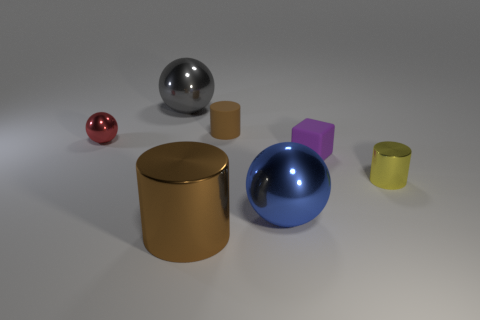Do the big brown shiny object and the yellow thing have the same shape?
Offer a very short reply. Yes. What is the color of the small rubber block?
Provide a succinct answer. Purple. What number of other objects are there of the same material as the yellow cylinder?
Keep it short and to the point. 4. What number of red objects are blocks or big spheres?
Your response must be concise. 0. Does the purple rubber thing in front of the tiny brown object have the same shape as the metal object to the right of the purple block?
Provide a short and direct response. No. There is a small metal ball; is its color the same as the metallic object behind the small brown matte cylinder?
Ensure brevity in your answer.  No. There is a big thing in front of the blue shiny ball; is its color the same as the matte cylinder?
Your answer should be compact. Yes. What number of things are either tiny shiny balls or small metallic objects that are on the left side of the gray sphere?
Keep it short and to the point. 1. There is a thing that is on the right side of the large blue metallic thing and left of the tiny yellow metal object; what is its material?
Give a very brief answer. Rubber. What is the brown cylinder that is in front of the red object made of?
Keep it short and to the point. Metal. 